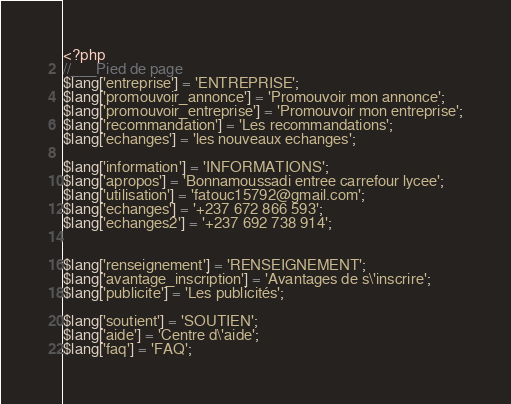<code> <loc_0><loc_0><loc_500><loc_500><_PHP_><?php
//___Pied de page
$lang['entreprise'] = 'ENTREPRISE';
$lang['promouvoir_annonce'] = 'Promouvoir mon annonce';
$lang['promouvoir_entreprise'] = 'Promouvoir mon entreprise';
$lang['recommandation'] = 'Les recommandations';
$lang['echanges'] = 'les nouveaux echanges';

$lang['information'] = 'INFORMATIONS';
$lang['apropos'] = 'Bonnamoussadi entree carrefour lycee';
$lang['utilisation'] = 'fatouc15792@gmail.com'; 
$lang['echanges'] = '+237 672 866 593';
$lang['echanges2'] = '+237 692 738 914';


$lang['renseignement'] = 'RENSEIGNEMENT'; 
$lang['avantage_inscription'] = 'Avantages de s\'inscrire';
$lang['publicite'] = 'Les publicités'; 

$lang['soutient'] = 'SOUTIEN';
$lang['aide'] = 'Centre d\'aide';
$lang['faq'] = 'FAQ'; </code> 